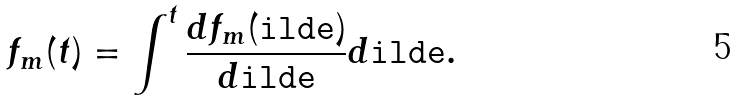Convert formula to latex. <formula><loc_0><loc_0><loc_500><loc_500>f _ { m } ( t ) = \int ^ { t } \frac { d f _ { m } ( \tt i l d e ) } { d \tt i l d e } d \tt i l d e .</formula> 